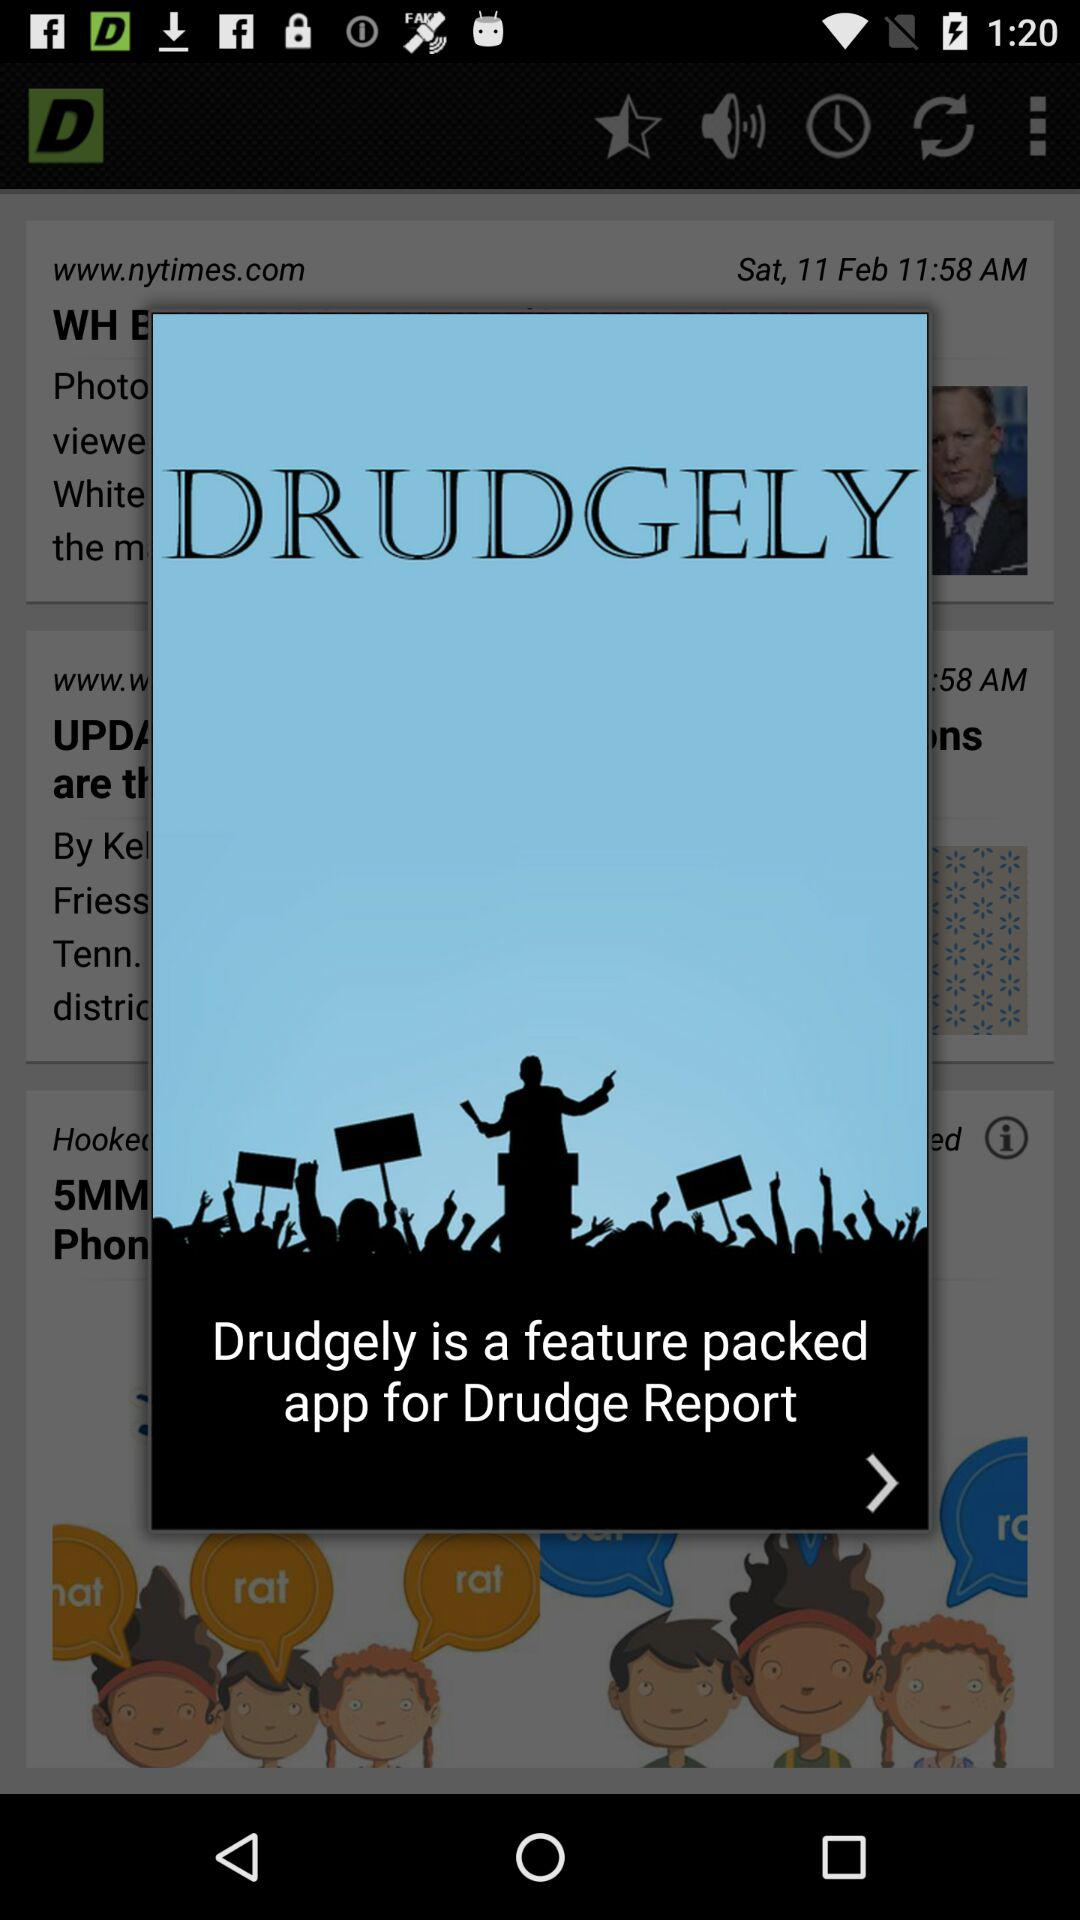What is the name of the application? The name of the application is "DRUDGELY". 